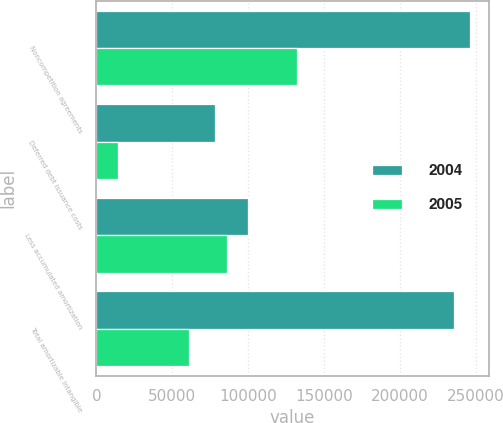Convert chart to OTSL. <chart><loc_0><loc_0><loc_500><loc_500><stacked_bar_chart><ecel><fcel>Noncompetition agreements<fcel>Deferred debt issuance costs<fcel>Less accumulated amortization<fcel>Total amortizable intangible<nl><fcel>2004<fcel>246336<fcel>77884<fcel>100250<fcel>235944<nl><fcel>2005<fcel>132503<fcel>14005<fcel>85789<fcel>60719<nl></chart> 